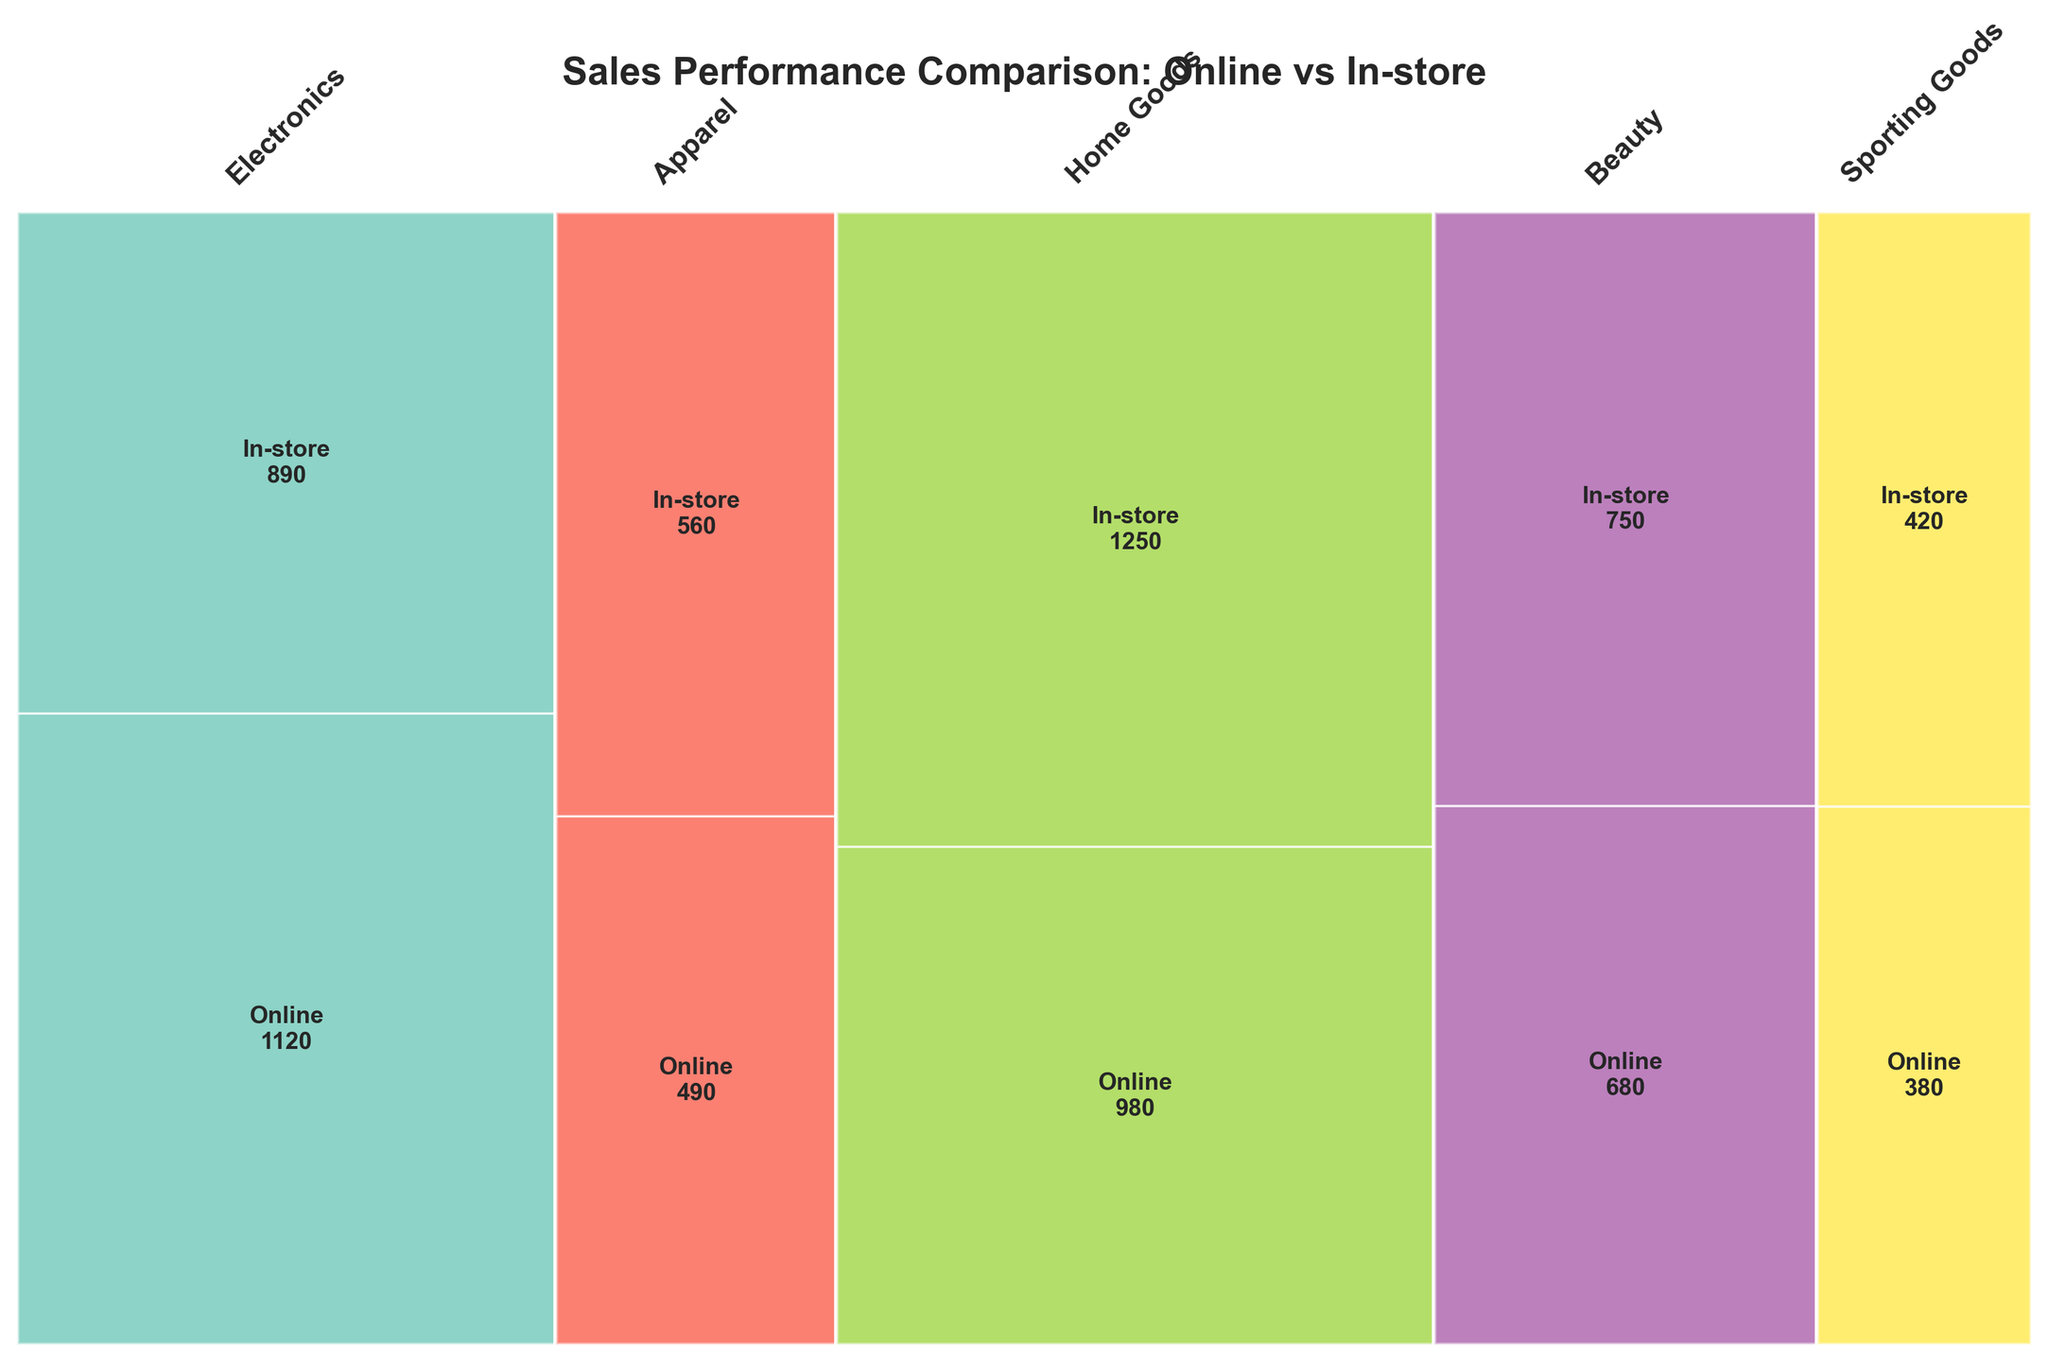What is the title of the figure? The title is usually displayed at the top of a figure and is intended to give a brief description of what the figure represents.
Answer: Sales Performance Comparison: Online vs In-store How many product lines are compared in the figure? To determine the number of product lines, we count the number of unique sections along the x-axis, each labeled with a product line's name.
Answer: 5 Which product line has the highest total sales volume? We need to look at the widths of the rectangles representing each product line. The width indicates the proportion of total sales. The widest rectangle represents the product line with the highest total sales volume.
Answer: Electronics Which sales channel contributes more to the sales of Apparel, Online or In-store? For the Apparel section, compare the height of the Online and In-store bars. The taller bar indicates the higher sales volume for that channel within Apparel.
Answer: In-store What's the sales volume of Beauty through the In-store channel? Look for the rectangle corresponding to Beauty and In-store. The text label inside or nearby the bar usually states the sales volume.
Answer: 490 Which product line shows the most balanced sales distribution between Online and In-store channels? Look for the product line where the two bars within the section are nearly the same height, indicating a similar sales volume for both channels.
Answer: Home Goods If we combine the total sales from Online and In-store channels, which product line has the second-highest sales volume? Compare the overall widths of the rectangles for each product line. Identify the second widest rectangle to determine the second-highest total sales volume.
Answer: Apparel How does the sales volume of Sporting Goods compare between Online and In-store channels? Compare the heights of the Online and In-store bars specifically for the Sporting Goods section. The taller bar indicates the higher sales volume.
Answer: Online > In-store What's the difference in sales volume between Online and In-store for Electronics? Find the sales volumes for the Online and In-store channels within the Electronics section. Subtract the lower value from the higher one to determine the difference.
Answer: 270 What visual cue indicates the division of sales channels within each product line in the figure? The figure uses different heights within each section to represent the sales volumes of Online and In-store channels within each product line.
Answer: Heights of rectangles 